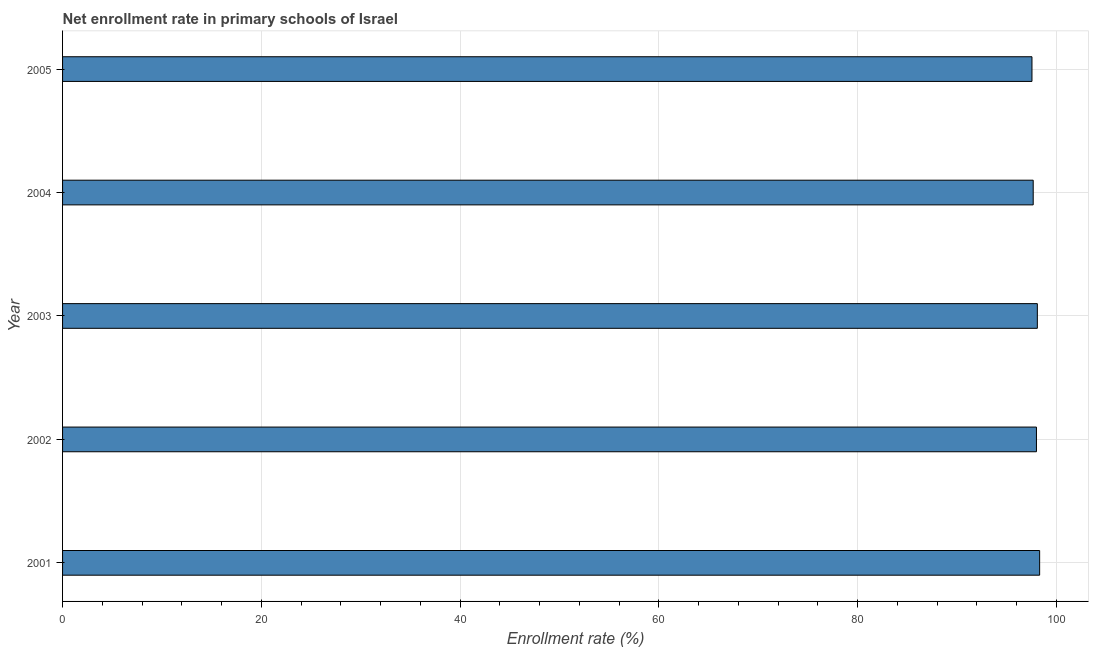Does the graph contain any zero values?
Make the answer very short. No. Does the graph contain grids?
Ensure brevity in your answer.  Yes. What is the title of the graph?
Provide a succinct answer. Net enrollment rate in primary schools of Israel. What is the label or title of the X-axis?
Your answer should be compact. Enrollment rate (%). What is the net enrollment rate in primary schools in 2002?
Your answer should be compact. 97.99. Across all years, what is the maximum net enrollment rate in primary schools?
Make the answer very short. 98.31. Across all years, what is the minimum net enrollment rate in primary schools?
Make the answer very short. 97.54. In which year was the net enrollment rate in primary schools maximum?
Ensure brevity in your answer.  2001. What is the sum of the net enrollment rate in primary schools?
Offer a very short reply. 489.58. What is the difference between the net enrollment rate in primary schools in 2003 and 2005?
Your answer should be compact. 0.54. What is the average net enrollment rate in primary schools per year?
Your answer should be compact. 97.92. What is the median net enrollment rate in primary schools?
Give a very brief answer. 97.99. In how many years, is the net enrollment rate in primary schools greater than 96 %?
Give a very brief answer. 5. Is the net enrollment rate in primary schools in 2001 less than that in 2002?
Your answer should be very brief. No. Is the difference between the net enrollment rate in primary schools in 2001 and 2005 greater than the difference between any two years?
Offer a terse response. Yes. What is the difference between the highest and the second highest net enrollment rate in primary schools?
Make the answer very short. 0.23. What is the difference between the highest and the lowest net enrollment rate in primary schools?
Offer a very short reply. 0.77. In how many years, is the net enrollment rate in primary schools greater than the average net enrollment rate in primary schools taken over all years?
Give a very brief answer. 3. Are all the bars in the graph horizontal?
Provide a succinct answer. Yes. How many years are there in the graph?
Your response must be concise. 5. Are the values on the major ticks of X-axis written in scientific E-notation?
Your answer should be very brief. No. What is the Enrollment rate (%) of 2001?
Make the answer very short. 98.31. What is the Enrollment rate (%) in 2002?
Offer a terse response. 97.99. What is the Enrollment rate (%) of 2003?
Give a very brief answer. 98.08. What is the Enrollment rate (%) in 2004?
Provide a succinct answer. 97.66. What is the Enrollment rate (%) in 2005?
Offer a very short reply. 97.54. What is the difference between the Enrollment rate (%) in 2001 and 2002?
Provide a short and direct response. 0.32. What is the difference between the Enrollment rate (%) in 2001 and 2003?
Offer a terse response. 0.23. What is the difference between the Enrollment rate (%) in 2001 and 2004?
Your answer should be compact. 0.65. What is the difference between the Enrollment rate (%) in 2001 and 2005?
Your answer should be compact. 0.77. What is the difference between the Enrollment rate (%) in 2002 and 2003?
Offer a terse response. -0.09. What is the difference between the Enrollment rate (%) in 2002 and 2004?
Make the answer very short. 0.33. What is the difference between the Enrollment rate (%) in 2002 and 2005?
Your response must be concise. 0.45. What is the difference between the Enrollment rate (%) in 2003 and 2004?
Offer a terse response. 0.42. What is the difference between the Enrollment rate (%) in 2003 and 2005?
Your answer should be compact. 0.54. What is the difference between the Enrollment rate (%) in 2004 and 2005?
Your answer should be very brief. 0.12. What is the ratio of the Enrollment rate (%) in 2001 to that in 2002?
Provide a short and direct response. 1. What is the ratio of the Enrollment rate (%) in 2001 to that in 2003?
Ensure brevity in your answer.  1. What is the ratio of the Enrollment rate (%) in 2001 to that in 2004?
Give a very brief answer. 1.01. What is the ratio of the Enrollment rate (%) in 2001 to that in 2005?
Keep it short and to the point. 1.01. What is the ratio of the Enrollment rate (%) in 2002 to that in 2004?
Offer a very short reply. 1. What is the ratio of the Enrollment rate (%) in 2004 to that in 2005?
Provide a short and direct response. 1. 